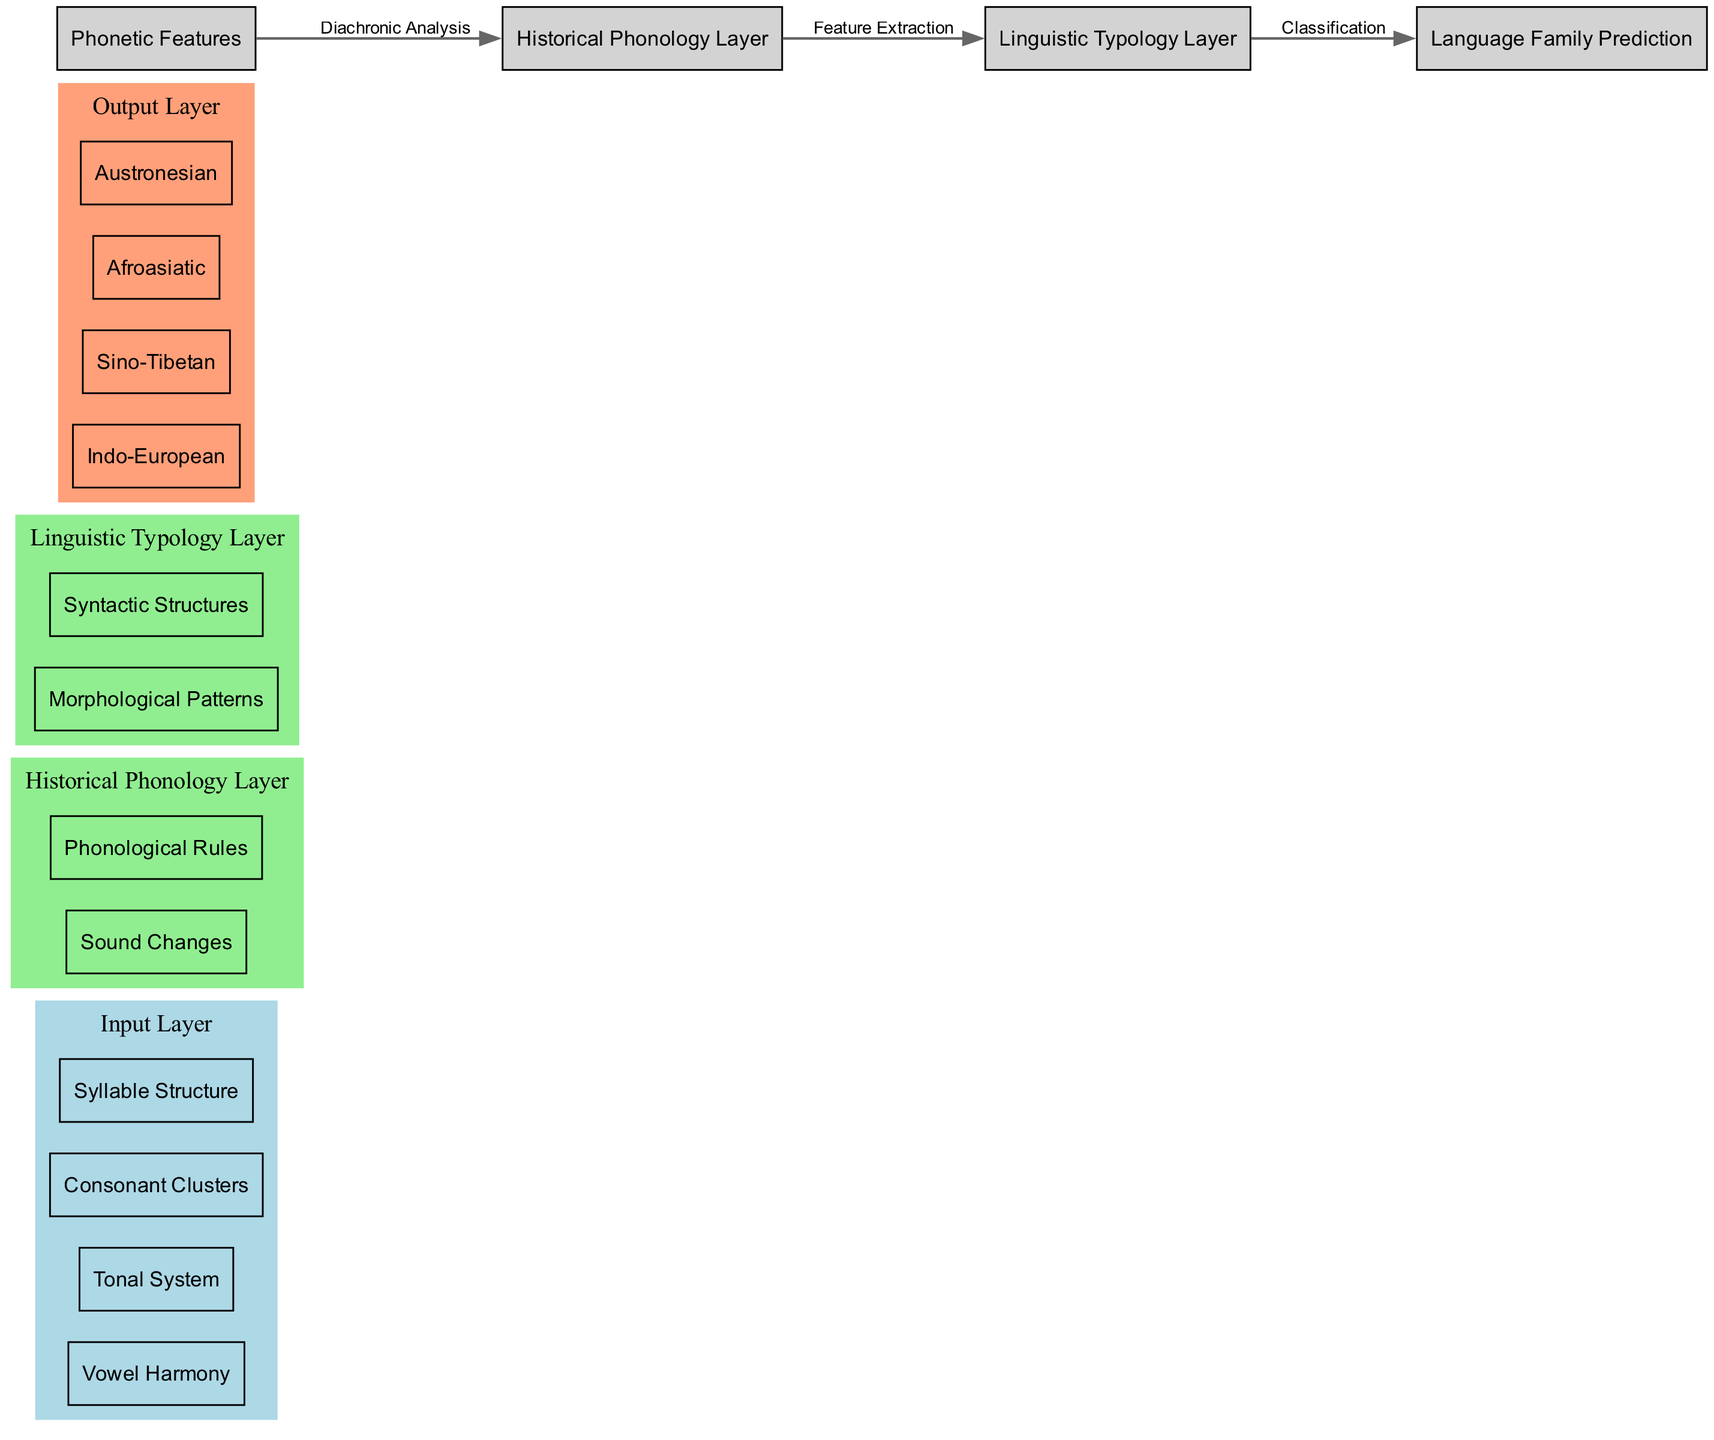What are the nodes in the input layer? The nodes in the input layer are specifically listed as phonetic features that serve as inputs for the neural network. They include Vowel Harmony, Tonal System, Consonant Clusters, and Syllable Structure.
Answer: Vowel Harmony, Tonal System, Consonant Clusters, Syllable Structure How many nodes are in the Historical Phonology Layer? The Historical Phonology Layer consists of two distinct nodes, which are Sound Changes and Phonological Rules. Thus, by counting these nodes, we find the total is two.
Answer: 2 What is the output layer labeled as? The output layer is categorized as Language Family Prediction, which can be seen as the final stage where predictions are generated based on the preceding layers' processing.
Answer: Language Family Prediction What connects the Historical Phonology Layer to the Linguistic Typology Layer? The connection from the Historical Phonology Layer to the Linguistic Typology Layer is labeled as Feature Extraction, indicating that features are being distilled for further classification.
Answer: Feature Extraction Which layer comes after the input layer? The layer that follows the input layer, as indicated in the diagram flow, is the Historical Phonology Layer, leading to the next stage of processing phonetic features.
Answer: Historical Phonology Layer How many language families are predicted in the output layer? The output layer predicts four distinct language families: Indo-European, Sino-Tibetan, Afroasiatic, and Austronesian, which can be counted directly from the labeled nodes in the output layer.
Answer: 4 What is the connection from the Linguistic Typology Layer to the output layer labeled as? The connection that leads from the Linguistic Typology Layer to the output layer is designated as Classification, which signifies the final decision-making step of the neural network's processing.
Answer: Classification Which phonetic feature is included in the input layer? The input layer features several phonetic attributes, including Vowel Harmony, which is specifically mentioned among the initial nodes of the structure.
Answer: Vowel Harmony What does the diagram represent in its entirety? The diagram represents a neural network architecture specifically designed for predicting language families based on phonetic features, illustrating the flow and processing stages involved.
Answer: Predicting language families based on phonetic features 